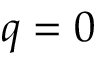<formula> <loc_0><loc_0><loc_500><loc_500>q = 0</formula> 